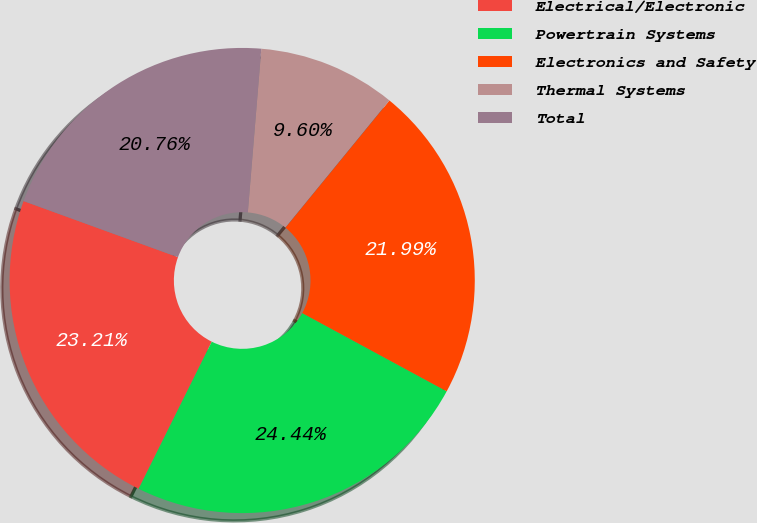Convert chart. <chart><loc_0><loc_0><loc_500><loc_500><pie_chart><fcel>Electrical/Electronic<fcel>Powertrain Systems<fcel>Electronics and Safety<fcel>Thermal Systems<fcel>Total<nl><fcel>23.21%<fcel>24.44%<fcel>21.99%<fcel>9.6%<fcel>20.76%<nl></chart> 